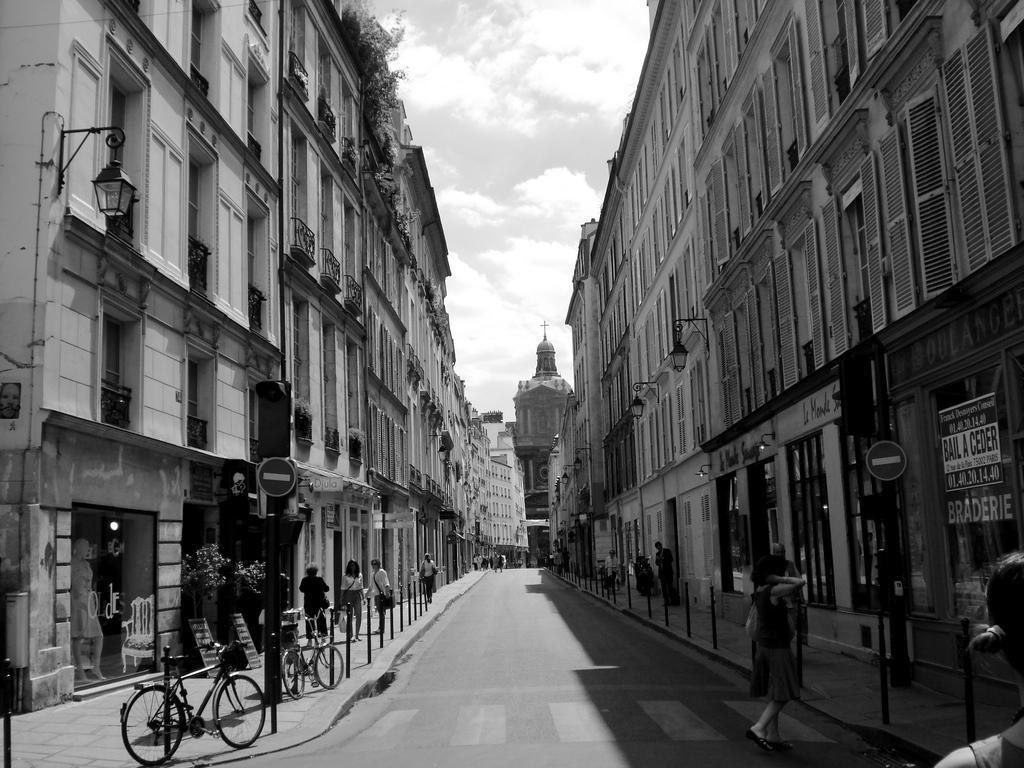Could you give a brief overview of what you see in this image? This is a black and white image and here we can see people and bicycles and in the background, there are buildings, plants and lights and there is a tower. At the bottom, there is road and a side walk and we can see some poles and sign boards. At the top, there are clouds in the sky. 